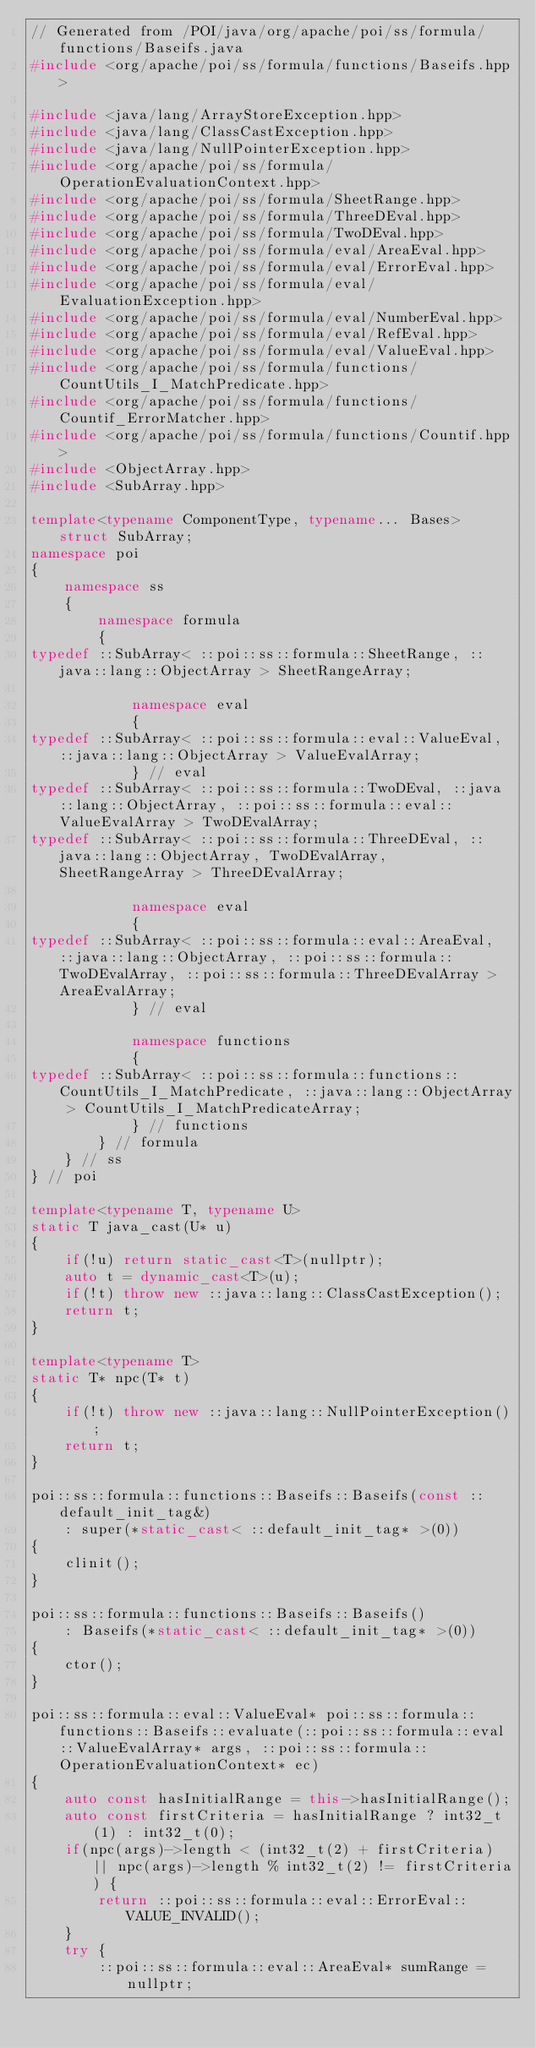<code> <loc_0><loc_0><loc_500><loc_500><_C++_>// Generated from /POI/java/org/apache/poi/ss/formula/functions/Baseifs.java
#include <org/apache/poi/ss/formula/functions/Baseifs.hpp>

#include <java/lang/ArrayStoreException.hpp>
#include <java/lang/ClassCastException.hpp>
#include <java/lang/NullPointerException.hpp>
#include <org/apache/poi/ss/formula/OperationEvaluationContext.hpp>
#include <org/apache/poi/ss/formula/SheetRange.hpp>
#include <org/apache/poi/ss/formula/ThreeDEval.hpp>
#include <org/apache/poi/ss/formula/TwoDEval.hpp>
#include <org/apache/poi/ss/formula/eval/AreaEval.hpp>
#include <org/apache/poi/ss/formula/eval/ErrorEval.hpp>
#include <org/apache/poi/ss/formula/eval/EvaluationException.hpp>
#include <org/apache/poi/ss/formula/eval/NumberEval.hpp>
#include <org/apache/poi/ss/formula/eval/RefEval.hpp>
#include <org/apache/poi/ss/formula/eval/ValueEval.hpp>
#include <org/apache/poi/ss/formula/functions/CountUtils_I_MatchPredicate.hpp>
#include <org/apache/poi/ss/formula/functions/Countif_ErrorMatcher.hpp>
#include <org/apache/poi/ss/formula/functions/Countif.hpp>
#include <ObjectArray.hpp>
#include <SubArray.hpp>

template<typename ComponentType, typename... Bases> struct SubArray;
namespace poi
{
    namespace ss
    {
        namespace formula
        {
typedef ::SubArray< ::poi::ss::formula::SheetRange, ::java::lang::ObjectArray > SheetRangeArray;

            namespace eval
            {
typedef ::SubArray< ::poi::ss::formula::eval::ValueEval, ::java::lang::ObjectArray > ValueEvalArray;
            } // eval
typedef ::SubArray< ::poi::ss::formula::TwoDEval, ::java::lang::ObjectArray, ::poi::ss::formula::eval::ValueEvalArray > TwoDEvalArray;
typedef ::SubArray< ::poi::ss::formula::ThreeDEval, ::java::lang::ObjectArray, TwoDEvalArray, SheetRangeArray > ThreeDEvalArray;

            namespace eval
            {
typedef ::SubArray< ::poi::ss::formula::eval::AreaEval, ::java::lang::ObjectArray, ::poi::ss::formula::TwoDEvalArray, ::poi::ss::formula::ThreeDEvalArray > AreaEvalArray;
            } // eval

            namespace functions
            {
typedef ::SubArray< ::poi::ss::formula::functions::CountUtils_I_MatchPredicate, ::java::lang::ObjectArray > CountUtils_I_MatchPredicateArray;
            } // functions
        } // formula
    } // ss
} // poi

template<typename T, typename U>
static T java_cast(U* u)
{
    if(!u) return static_cast<T>(nullptr);
    auto t = dynamic_cast<T>(u);
    if(!t) throw new ::java::lang::ClassCastException();
    return t;
}

template<typename T>
static T* npc(T* t)
{
    if(!t) throw new ::java::lang::NullPointerException();
    return t;
}

poi::ss::formula::functions::Baseifs::Baseifs(const ::default_init_tag&)
    : super(*static_cast< ::default_init_tag* >(0))
{
    clinit();
}

poi::ss::formula::functions::Baseifs::Baseifs()
    : Baseifs(*static_cast< ::default_init_tag* >(0))
{
    ctor();
}

poi::ss::formula::eval::ValueEval* poi::ss::formula::functions::Baseifs::evaluate(::poi::ss::formula::eval::ValueEvalArray* args, ::poi::ss::formula::OperationEvaluationContext* ec)
{
    auto const hasInitialRange = this->hasInitialRange();
    auto const firstCriteria = hasInitialRange ? int32_t(1) : int32_t(0);
    if(npc(args)->length < (int32_t(2) + firstCriteria) || npc(args)->length % int32_t(2) != firstCriteria) {
        return ::poi::ss::formula::eval::ErrorEval::VALUE_INVALID();
    }
    try {
        ::poi::ss::formula::eval::AreaEval* sumRange = nullptr;</code> 